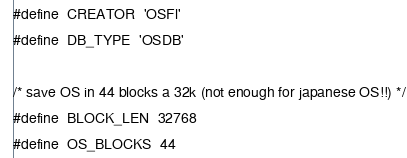Convert code to text. <code><loc_0><loc_0><loc_500><loc_500><_C_>
#define  CREATOR  'OSFl'
#define  DB_TYPE  'OSDB'

/* save OS in 44 blocks a 32k (not enough for japanese OS!!) */
#define  BLOCK_LEN  32768
#define  OS_BLOCKS  44
</code> 